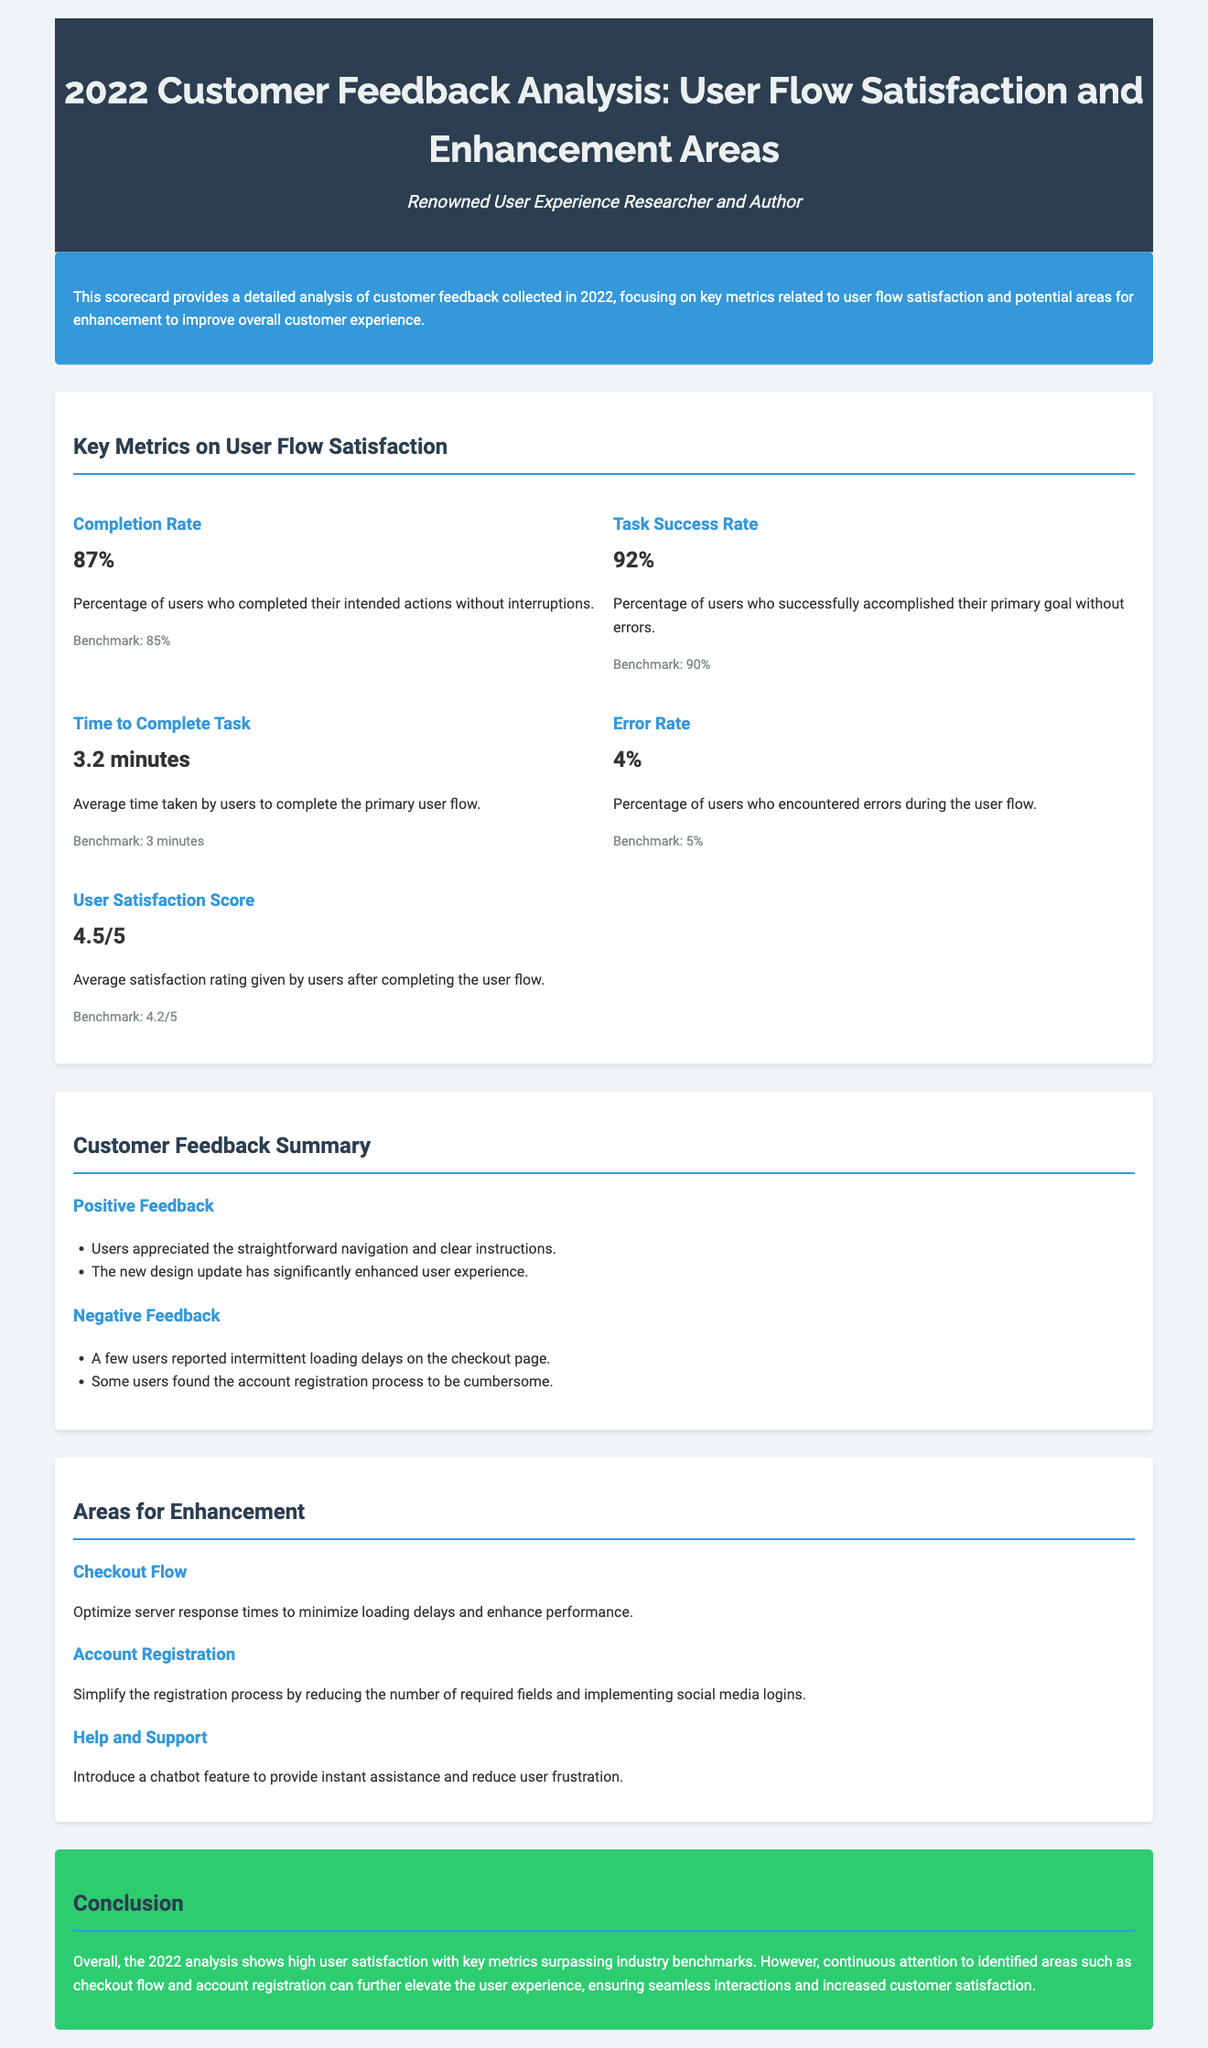What is the Completion Rate? The Completion Rate is the percentage of users who completed their intended actions without interruptions, which is 87%.
Answer: 87% What is the User Satisfaction Score? The User Satisfaction Score is an average rating given by users after completing the user flow, which is 4.5 out of 5.
Answer: 4.5/5 What was the Time to Complete Task? The Time to Complete Task is the average time taken by users to complete the primary user flow, which is 3.2 minutes.
Answer: 3.2 minutes What is the Negative Feedback regarding the checkout page? Negative feedback includes intermittent loading delays on the checkout page.
Answer: Intermittent loading delays What area is suggested for improvement related to Account Registration? It is suggested to simplify the registration process by reducing the number of required fields.
Answer: Simplify registration process What is the benchmark for the Error Rate? The benchmark for the Error Rate is set at 5%.
Answer: 5% How many areas for enhancement are mentioned? Three areas for enhancement are mentioned: Checkout Flow, Account Registration, and Help and Support.
Answer: Three What percentage of users successfully accomplished their primary goal? The percentage of users who successfully accomplished their primary goal is 92%.
Answer: 92% What is the suggested improvement for the Help and Support area? Introducing a chatbot feature is suggested to provide instant assistance.
Answer: Introduce chatbot feature 